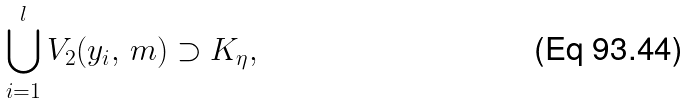<formula> <loc_0><loc_0><loc_500><loc_500>\bigcup _ { i = 1 } ^ { l } V _ { 2 } ( y _ { i } , \, m ) \supset K _ { \eta } ,</formula> 